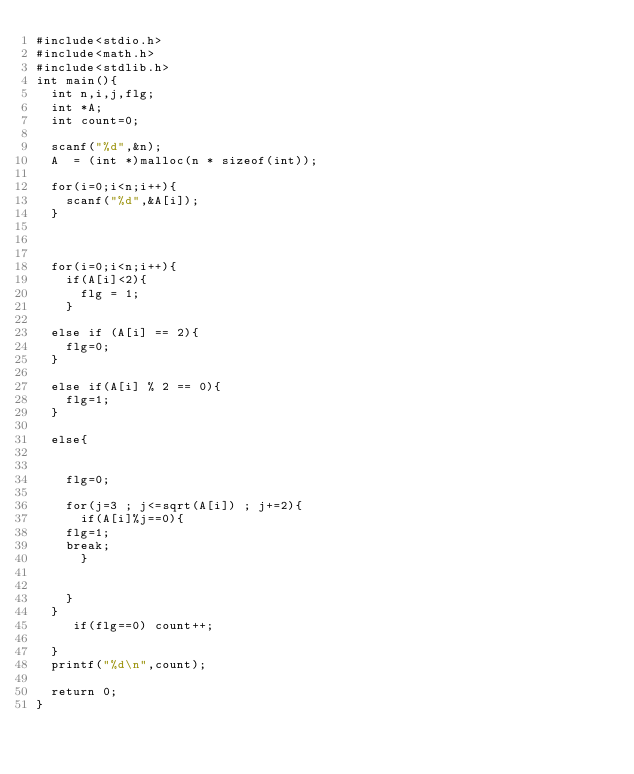Convert code to text. <code><loc_0><loc_0><loc_500><loc_500><_C_>#include<stdio.h>
#include<math.h>
#include<stdlib.h>
int main(){
  int n,i,j,flg;
  int *A;
  int count=0;
  
  scanf("%d",&n);
  A  = (int *)malloc(n * sizeof(int));

  for(i=0;i<n;i++){
    scanf("%d",&A[i]);
  }
  

  
  for(i=0;i<n;i++){
    if(A[i]<2){
      flg = 1;
	}
    
  else if (A[i] == 2){
    flg=0;
  }

  else if(A[i] % 2 == 0){ 
    flg=1;
  }

  else{

    
    flg=0;
    
    for(j=3 ; j<=sqrt(A[i]) ; j+=2){
      if(A[i]%j==0){
	flg=1;
	break;
      }
      
      
    }
  }
     if(flg==0) count++;
      
  }
  printf("%d\n",count);

  return 0;
}

</code> 